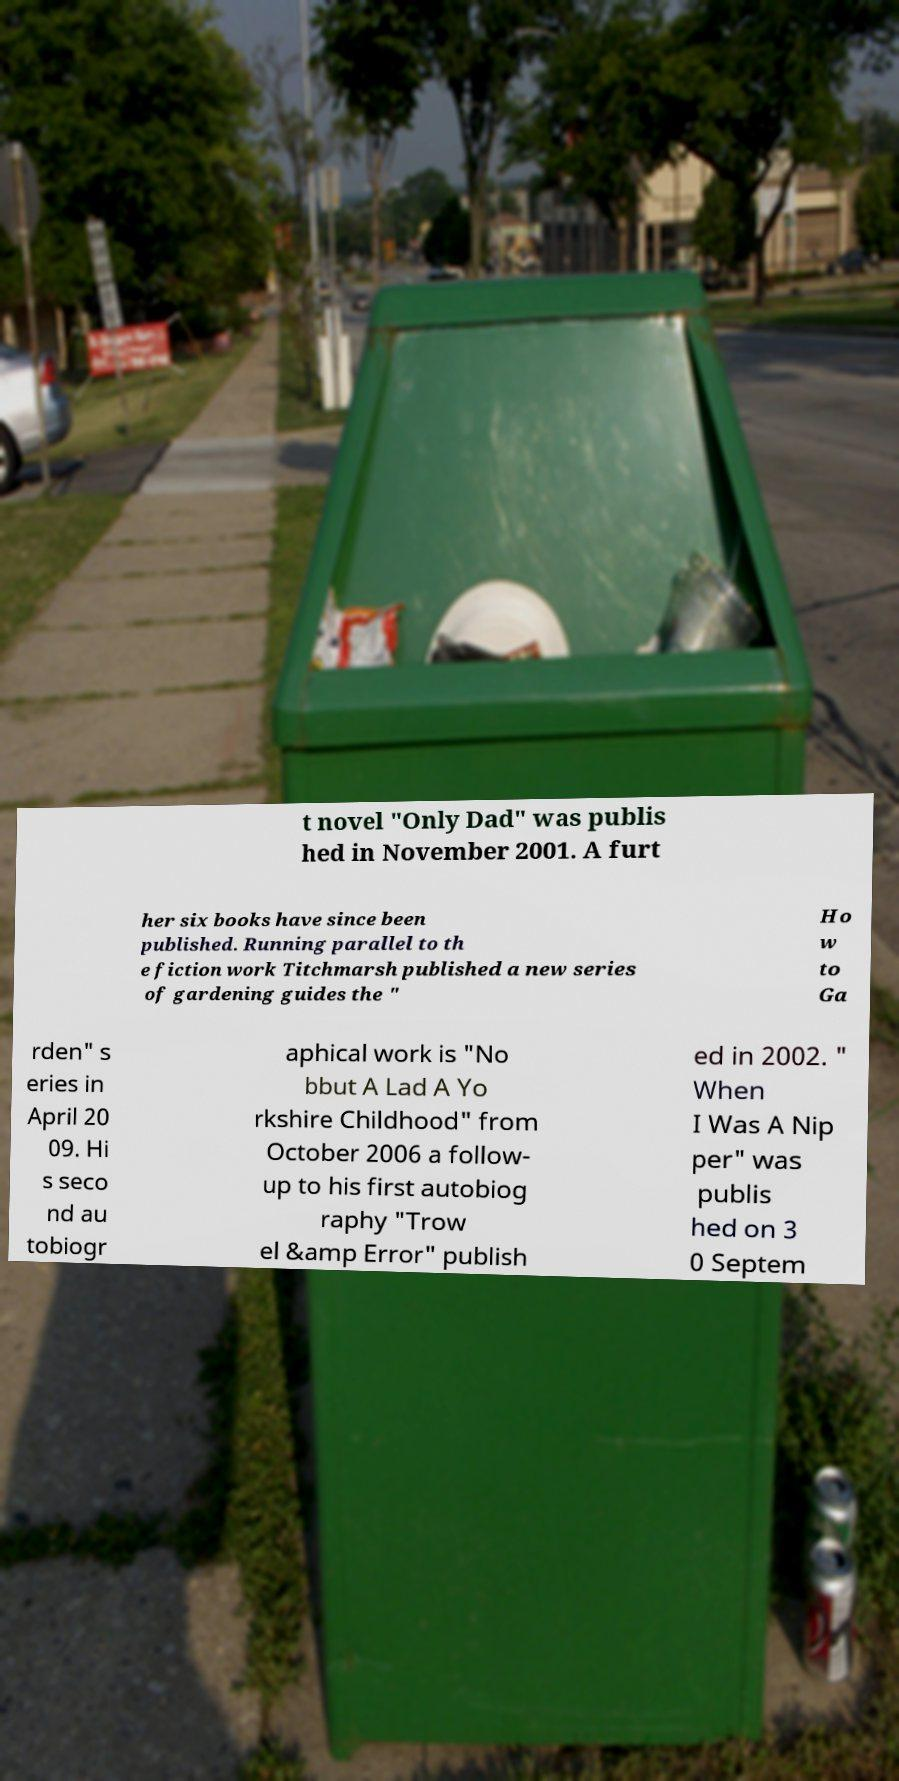There's text embedded in this image that I need extracted. Can you transcribe it verbatim? t novel "Only Dad" was publis hed in November 2001. A furt her six books have since been published. Running parallel to th e fiction work Titchmarsh published a new series of gardening guides the " Ho w to Ga rden" s eries in April 20 09. Hi s seco nd au tobiogr aphical work is "No bbut A Lad A Yo rkshire Childhood" from October 2006 a follow- up to his first autobiog raphy "Trow el &amp Error" publish ed in 2002. " When I Was A Nip per" was publis hed on 3 0 Septem 